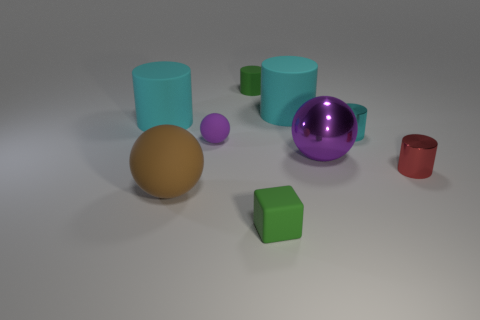How does the lighting affect the appearance of these objects? The lighting in the image creates soft shadows and highlights, which enhances the three-dimensionality of the objects. It also affects the color's perception; for instance, the shadows give a richer tone to the colors. The reflective materials on the cyan cylinder and purple sphere show strong highlights, giving a sense of the light's direction and intensity. 